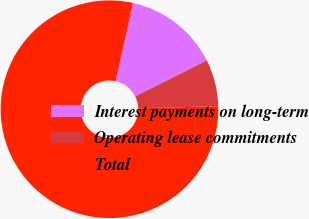Convert chart to OTSL. <chart><loc_0><loc_0><loc_500><loc_500><pie_chart><fcel>Interest payments on long-term<fcel>Operating lease commitments<fcel>Total<nl><fcel>14.14%<fcel>6.94%<fcel>78.92%<nl></chart> 